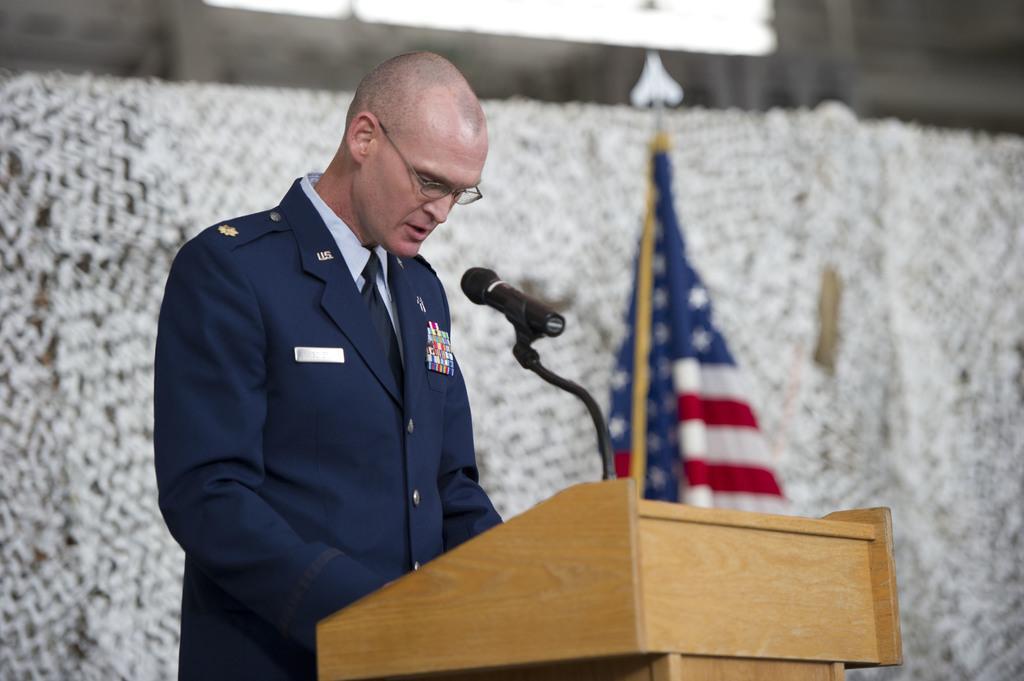In one or two sentences, can you explain what this image depicts? In this image, we can see a person with glasses is standing near the podium. Here there is a microphone with stand. Background there is a blur view. Here we can see a flag with pole. 